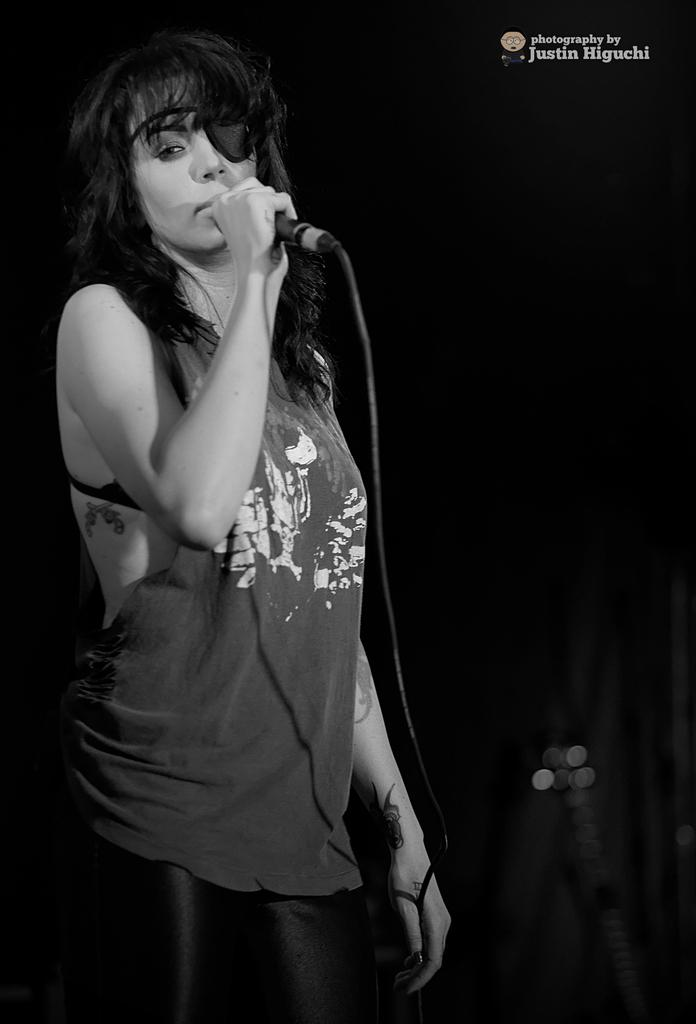What is the main subject of the image? The main subject of the image is a woman. What is the woman doing in the image? The woman is standing in the image. What object is the woman holding in her hand? The woman is holding a mic in her hand. What direction is the woman facing in the image? The direction the woman is facing cannot be determined from the image alone. What type of joke is the woman telling in the image? There is no indication in the image that the woman is telling a joke, as there is no context provided. 